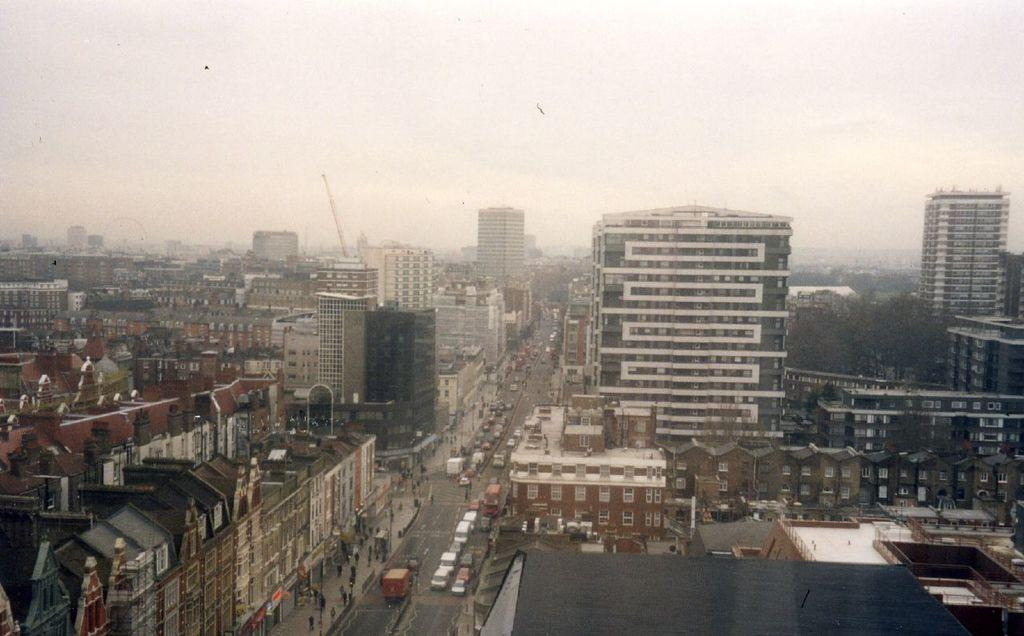What type of structures can be seen in the image? There are buildings in the image. What else is present in the image besides buildings? There is a road and vehicles in the image. Are there any living beings visible in the image? Yes, there are people in the image. What type of umbrella is being used for the distribution of volleyballs in the image? There is no umbrella, distribution, or volleyballs present in the image. 